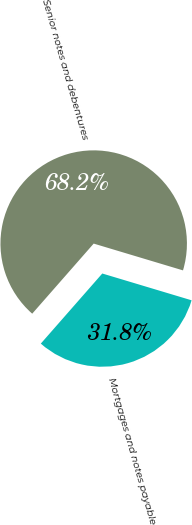Convert chart to OTSL. <chart><loc_0><loc_0><loc_500><loc_500><pie_chart><fcel>Mortgages and notes payable<fcel>Senior notes and debentures<nl><fcel>31.82%<fcel>68.18%<nl></chart> 